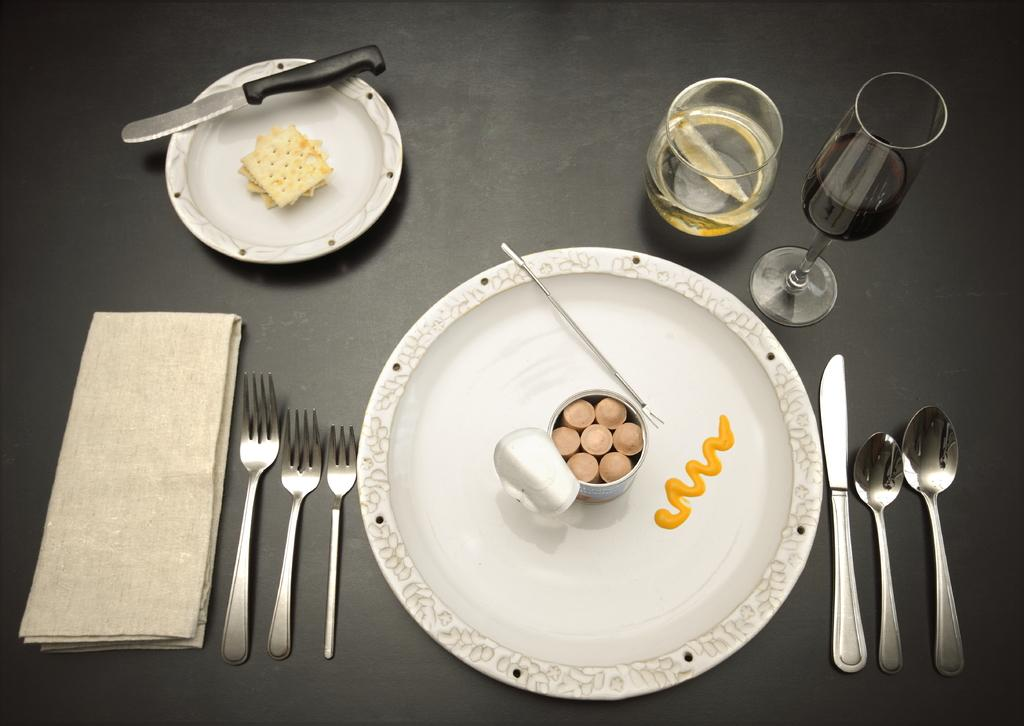How many plates are visible in the image? There are two plates in the image. What is on the plates? There are food items on the plates. What utensils and tableware are around the first plate? There are forks, knives, spoons, and glasses around the first plate, as well as a napkin. Where is the hall located in the image? There is no hall present in the image. What type of music can be heard playing in the background of the image? There is no music present in the image. 